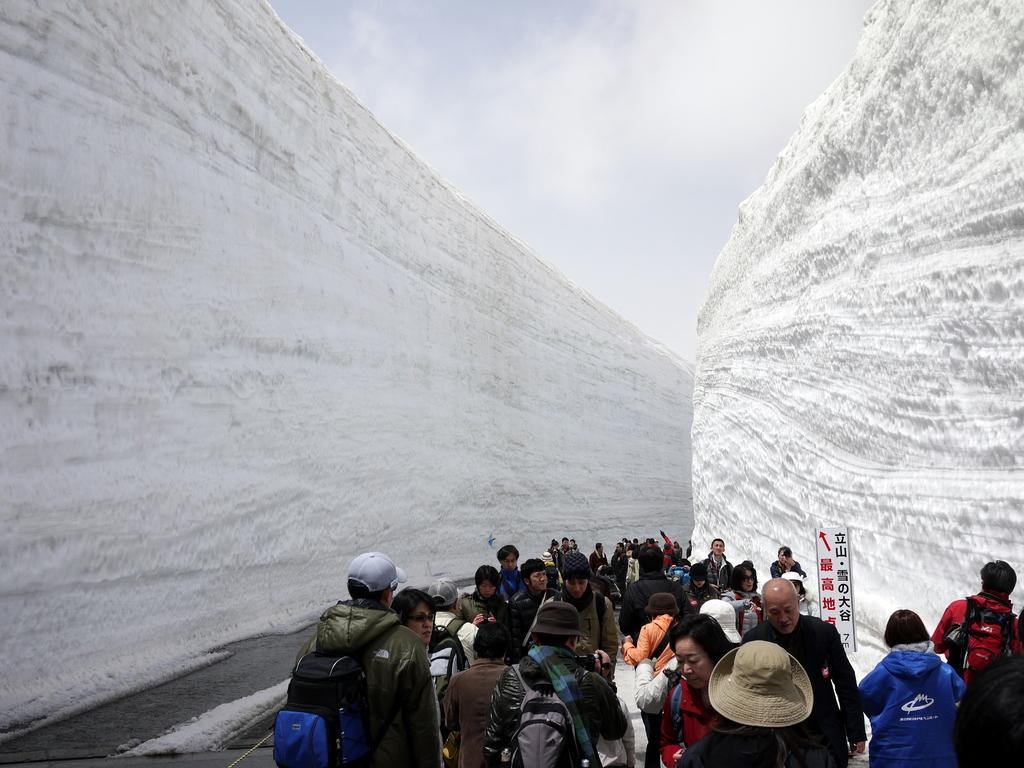What can be seen in the image involving people? There are people standing in the image. What natural features are present in the image? There are two mountains in the image. How are the mountains described in the image? The mountains are covered with snow. What is the condition of the sky in the image? The sky is cloudy in the image. What level of excitement can be observed in the cat in the image? There is no cat present in the image. How does the temper of the mountains affect the people in the image? The mountains do not have a temper, as they are inanimate objects. The people in the image are not affected by the mountains' temper. 